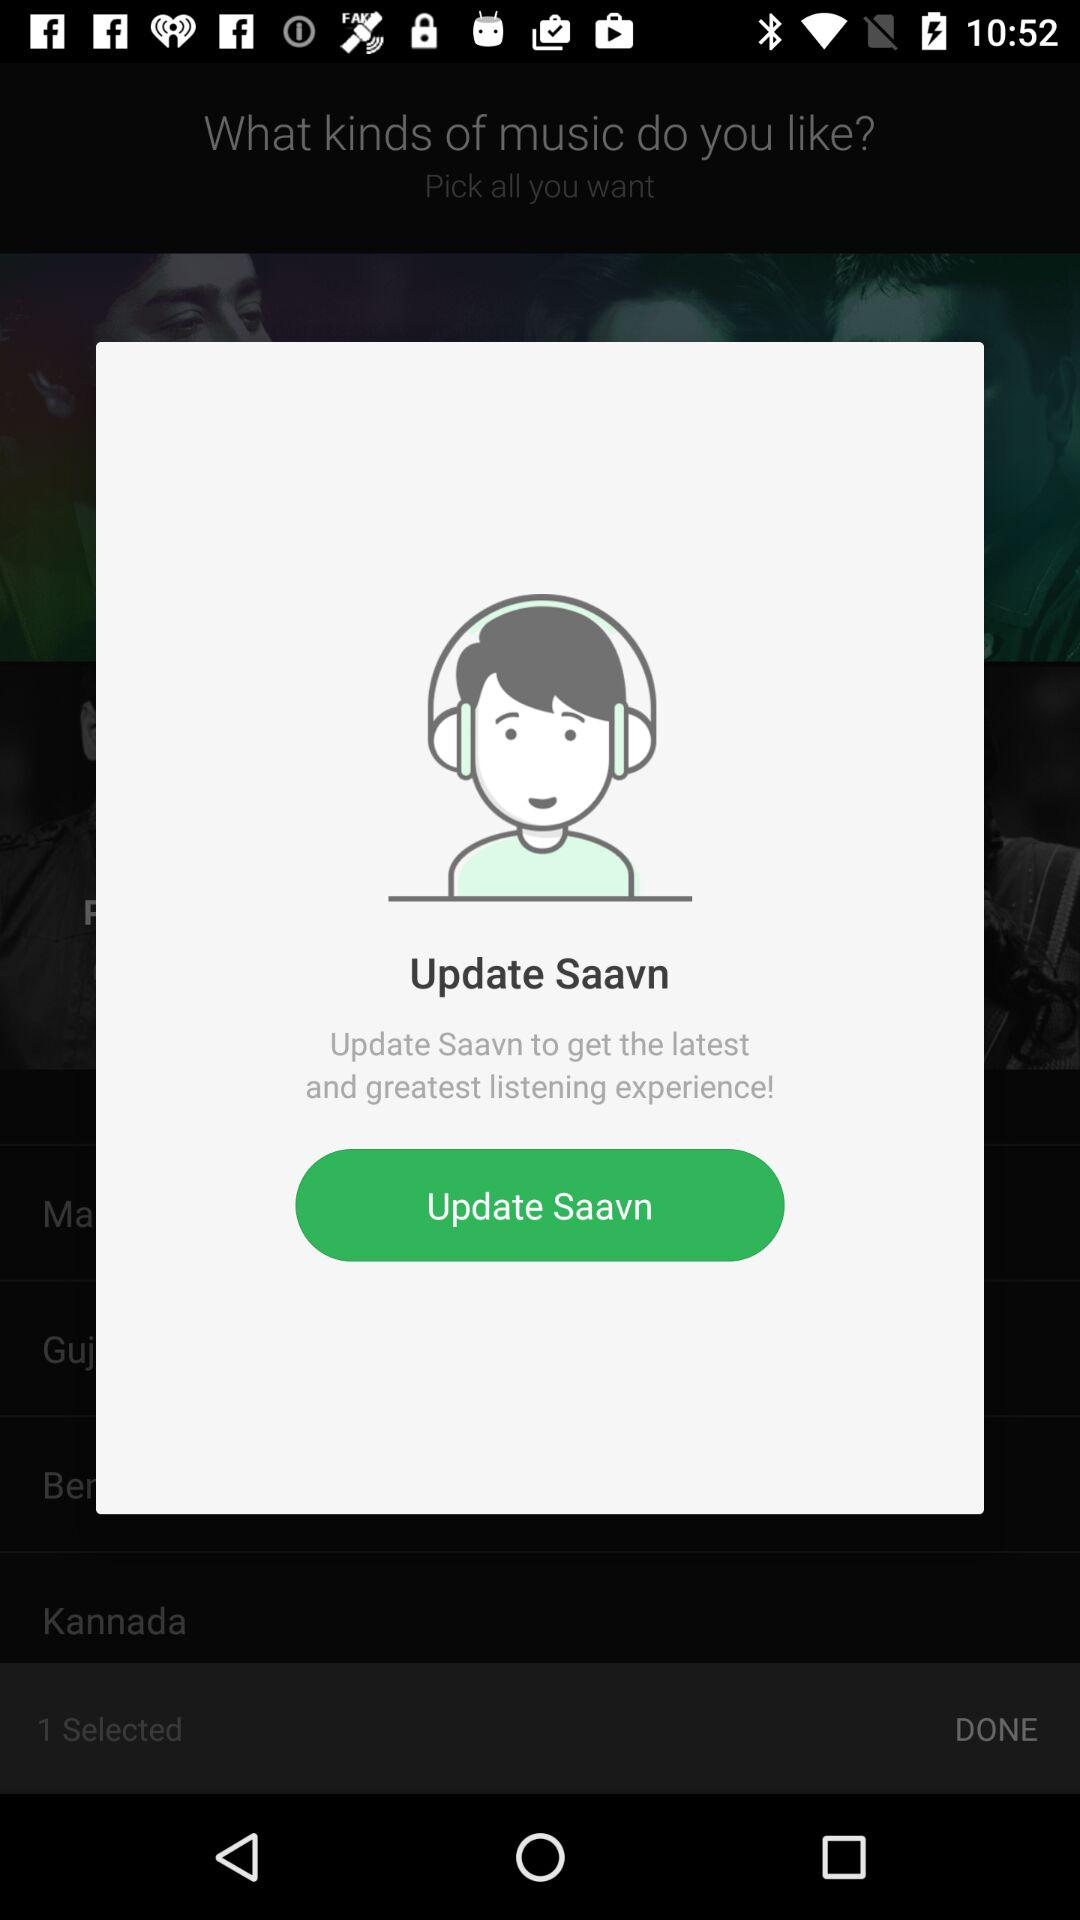What is the application name? The application name is "Saavn". 